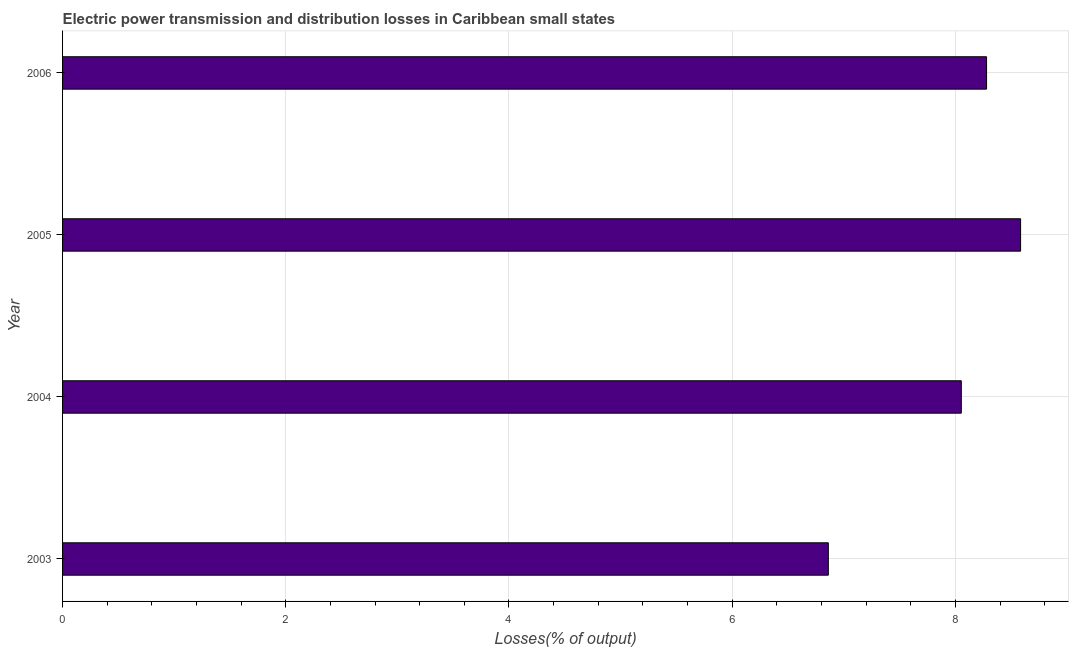Does the graph contain grids?
Make the answer very short. Yes. What is the title of the graph?
Your response must be concise. Electric power transmission and distribution losses in Caribbean small states. What is the label or title of the X-axis?
Ensure brevity in your answer.  Losses(% of output). What is the label or title of the Y-axis?
Keep it short and to the point. Year. What is the electric power transmission and distribution losses in 2005?
Ensure brevity in your answer.  8.58. Across all years, what is the maximum electric power transmission and distribution losses?
Your answer should be very brief. 8.58. Across all years, what is the minimum electric power transmission and distribution losses?
Your answer should be very brief. 6.86. In which year was the electric power transmission and distribution losses minimum?
Offer a terse response. 2003. What is the sum of the electric power transmission and distribution losses?
Ensure brevity in your answer.  31.78. What is the difference between the electric power transmission and distribution losses in 2003 and 2004?
Offer a very short reply. -1.19. What is the average electric power transmission and distribution losses per year?
Make the answer very short. 7.95. What is the median electric power transmission and distribution losses?
Ensure brevity in your answer.  8.17. What is the ratio of the electric power transmission and distribution losses in 2004 to that in 2005?
Provide a short and direct response. 0.94. What is the difference between the highest and the second highest electric power transmission and distribution losses?
Provide a succinct answer. 0.3. Is the sum of the electric power transmission and distribution losses in 2003 and 2005 greater than the maximum electric power transmission and distribution losses across all years?
Make the answer very short. Yes. What is the difference between the highest and the lowest electric power transmission and distribution losses?
Ensure brevity in your answer.  1.72. How many years are there in the graph?
Ensure brevity in your answer.  4. What is the Losses(% of output) of 2003?
Offer a terse response. 6.86. What is the Losses(% of output) in 2004?
Your answer should be compact. 8.05. What is the Losses(% of output) in 2005?
Ensure brevity in your answer.  8.58. What is the Losses(% of output) of 2006?
Offer a terse response. 8.28. What is the difference between the Losses(% of output) in 2003 and 2004?
Your answer should be very brief. -1.19. What is the difference between the Losses(% of output) in 2003 and 2005?
Your answer should be compact. -1.72. What is the difference between the Losses(% of output) in 2003 and 2006?
Offer a terse response. -1.42. What is the difference between the Losses(% of output) in 2004 and 2005?
Make the answer very short. -0.53. What is the difference between the Losses(% of output) in 2004 and 2006?
Provide a short and direct response. -0.23. What is the difference between the Losses(% of output) in 2005 and 2006?
Keep it short and to the point. 0.3. What is the ratio of the Losses(% of output) in 2003 to that in 2004?
Offer a terse response. 0.85. What is the ratio of the Losses(% of output) in 2003 to that in 2005?
Your answer should be very brief. 0.8. What is the ratio of the Losses(% of output) in 2003 to that in 2006?
Ensure brevity in your answer.  0.83. What is the ratio of the Losses(% of output) in 2004 to that in 2005?
Your answer should be very brief. 0.94. What is the ratio of the Losses(% of output) in 2004 to that in 2006?
Ensure brevity in your answer.  0.97. What is the ratio of the Losses(% of output) in 2005 to that in 2006?
Make the answer very short. 1.04. 